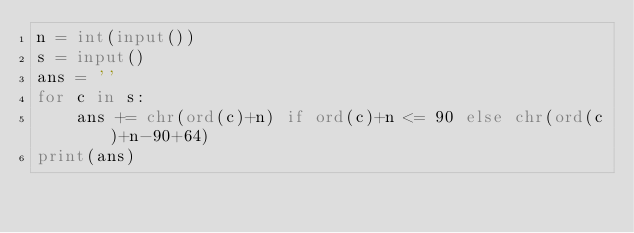Convert code to text. <code><loc_0><loc_0><loc_500><loc_500><_Python_>n = int(input())
s = input()
ans = ''
for c in s:
    ans += chr(ord(c)+n) if ord(c)+n <= 90 else chr(ord(c)+n-90+64)
print(ans)</code> 